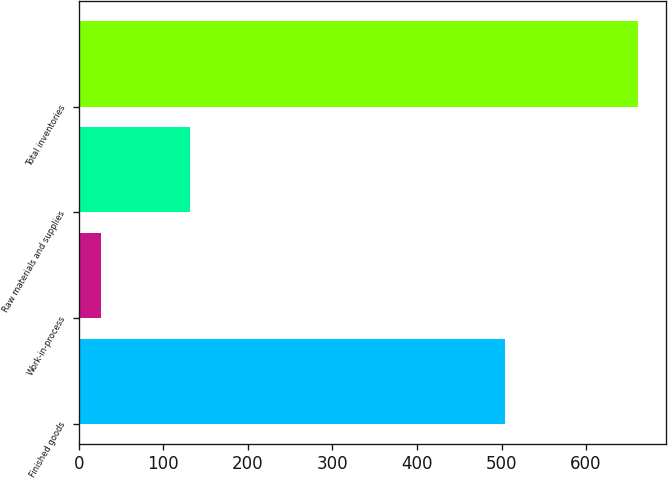Convert chart to OTSL. <chart><loc_0><loc_0><loc_500><loc_500><bar_chart><fcel>Finished goods<fcel>Work-in-process<fcel>Raw materials and supplies<fcel>Total inventories<nl><fcel>504<fcel>26<fcel>131<fcel>661<nl></chart> 